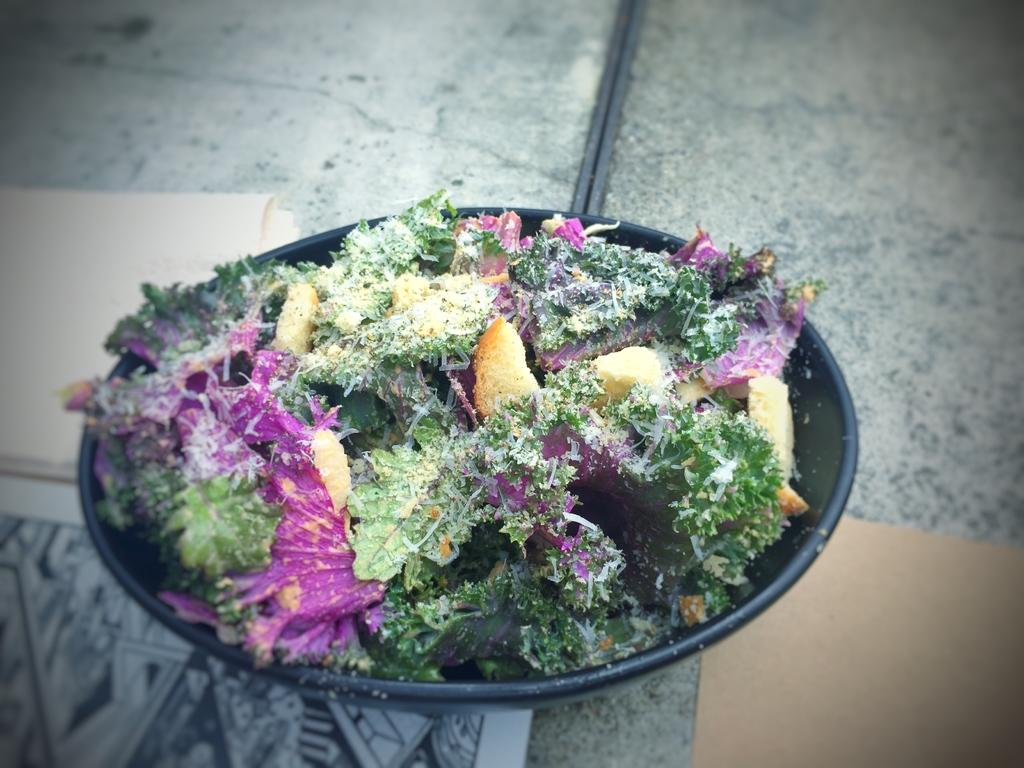What type of food is on the plate in the image? There is a plate containing salad in the image. What items are present on the table in the image? Napkins are placed on the table in the image. What type of insect can be seen sitting on the salad in the image? There is no insect present on the salad in the image. Is there a swing visible in the image? No, there is no swing present in the image. 